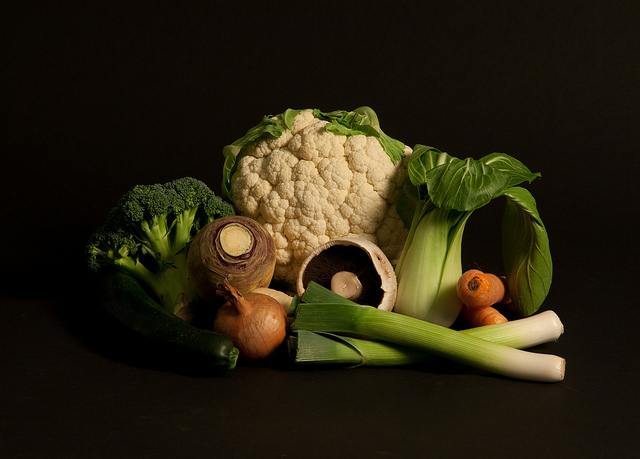Can you tell me about the best season to grow these vegetables? The vegetables shown vary in their growing seasons. Broccoli and cauliflower are cool-season crops, with planting times in early spring or late summer for a fall harvest. Leeks generally prefer cool weather as well and can be planted in early spring. Onions are also a cool-season crop, often planted as soon as the ground can be worked in spring. Portobello mushrooms aren't grown in traditional garden settings; they require a controlled environment with consistent temperatures and humidity, making them less dependent on seasonality. 